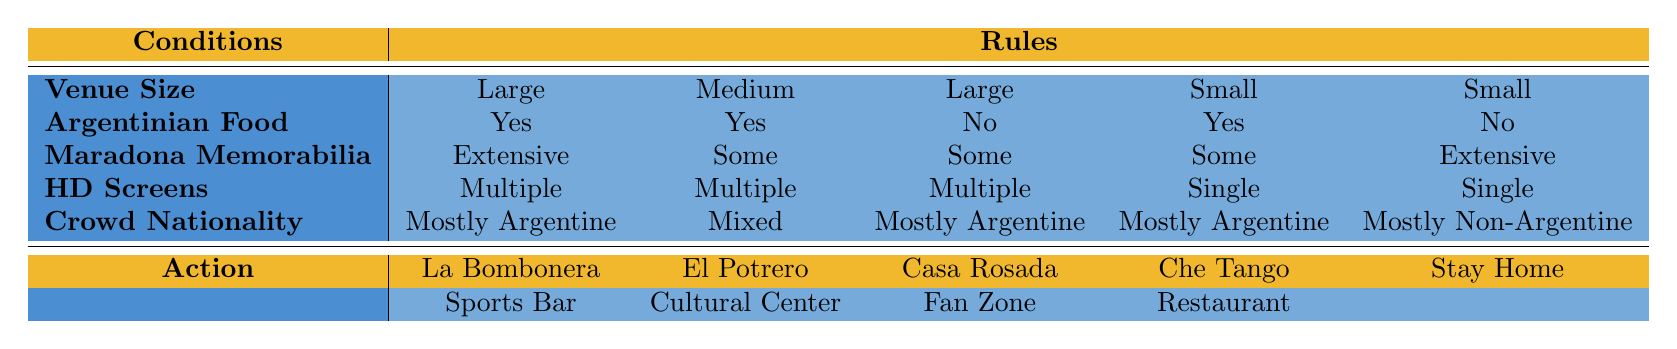What is the recommended venue if you want to go with a "Large" crowd that is "Mostly Argentine"? Looking at the table, there are two entries that match "Large" and "Mostly Argentine." The first is La Bombonera Sports Bar, which has additional conditions of "Yes" for Argentinian food and "Extensive" Maradona memorabilia, and the second is Casa Rosada Fan Zone, which has "No" for Argentinian food. Therefore, the recommendation would be La Bombonera Sports Bar, as it satisfies all the desired conditions.
Answer: La Bombonera Sports Bar Can you attend the Casa Rosada Fan Zone if there is "No" Argentinian food available? Yes, the Casa Rosada Fan Zone is listed under the conditions allowing for "No" Argentinian food, meaning it is indeed a viable option under that criterion.
Answer: Yes How many viewing options are available if you want a venue with "Extensive" Maradona memorabilia? There are two viewing options where "Extensive" Maradona memorabilia is available: La Bombonera Sports Bar and Stay at Home. Counting them gives a total of 2 options.
Answer: 2 What venue should you choose if you want to watch the game at home but still have "Some" Maradona memorabilia? The only venue listed that allows for "Stay at Home" and has "Extensive" Maradona memorabilia does not meet your requirement of "Some" memorabilia. Therefore, it's not an option, and you would have to either compromise on memorabilia or consider going elsewhere.
Answer: Not applicable/No option If you prefer a "Medium" venue with "Mixed" crowd, what would be the best option? The only possible choice for a "Medium" venue with a "Mixed" crowd is El Potrero Cultural Center, as it is the only entry matching those conditions in the table.
Answer: El Potrero Cultural Center Is there a venue that offers "Multiple" HD screens and "Yes" for Argentinian food but has a "Small" venue size? No, the options listed for a "Small" venue size either feature "Yes" for Argentinian food with "Single" HD screens or have "No" for Argentinian food with "Single" HD screens. Thus, there is no venue matching both conditions of "Multiple" HD screens and "Yes" food with a "Small" venue.
Answer: No What are the two viewing options available when the venue is "Small" and the crowd is "Mostly Argentine"? The two options available for a "Small" venue with "Mostly Argentine" crowds are Che Tango Restaurant Watch Party and Stay at Home. They are listed accordingly in the table under those conditions.
Answer: Che Tango Restaurant Watch Party, Stay at Home If I want to watch the match at a venue with "No" Argentinian food and "Some" Maradona memorabilia that accommodates a "Large" crowd, which venue should I choose? The only option available for a "Large" venue with "No" Argentinian food and "Some" Maradona memorabilia is Casa Rosada Fan Zone, so that would be the recommended choice.
Answer: Casa Rosada Fan Zone Which venues can accommodate more than 100 people and do not provide any Argentinian food options? The only venue that can accommodate a crowd larger than 100 and does not offer any Argentinian food is the Casa Rosada Fan Zone, as it matches those criteria in the table.
Answer: Casa Rosada Fan Zone 